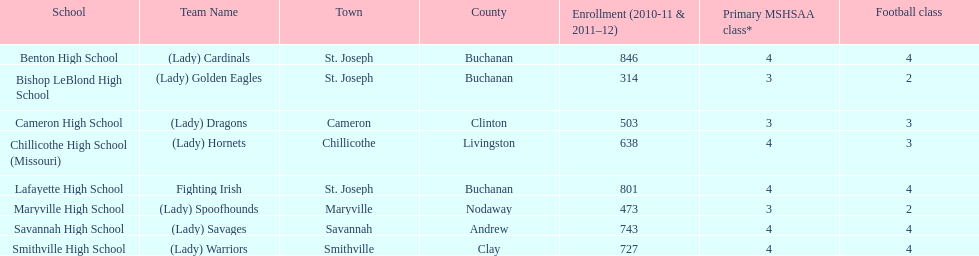Which school has the largest enrollment? Benton High School. 